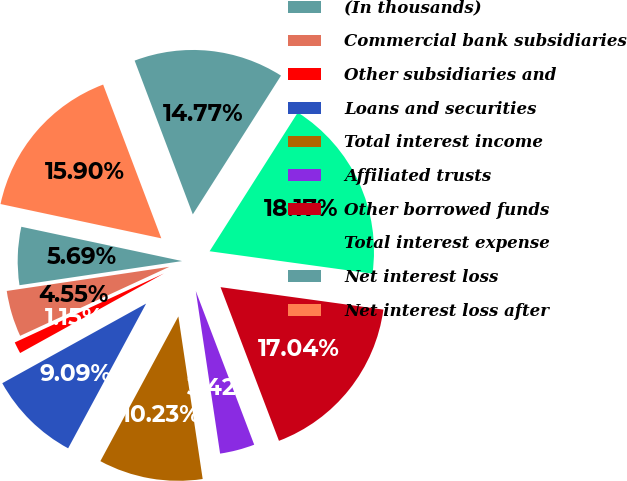<chart> <loc_0><loc_0><loc_500><loc_500><pie_chart><fcel>(In thousands)<fcel>Commercial bank subsidiaries<fcel>Other subsidiaries and<fcel>Loans and securities<fcel>Total interest income<fcel>Affiliated trusts<fcel>Other borrowed funds<fcel>Total interest expense<fcel>Net interest loss<fcel>Net interest loss after<nl><fcel>5.69%<fcel>4.55%<fcel>1.15%<fcel>9.09%<fcel>10.23%<fcel>3.42%<fcel>17.04%<fcel>18.17%<fcel>14.77%<fcel>15.9%<nl></chart> 